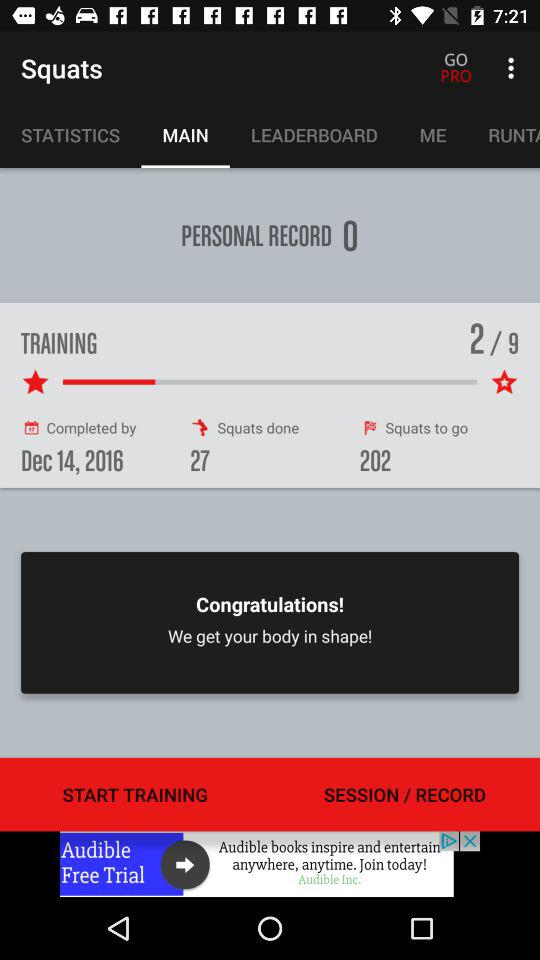What is the personal record? The personal record is 0. 